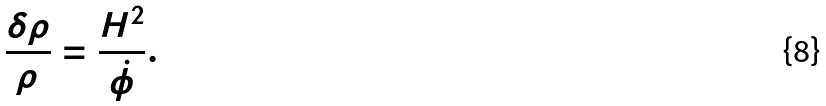<formula> <loc_0><loc_0><loc_500><loc_500>\frac { \delta \rho } { \rho } = \frac { H ^ { 2 } } { \dot { \phi } } .</formula> 